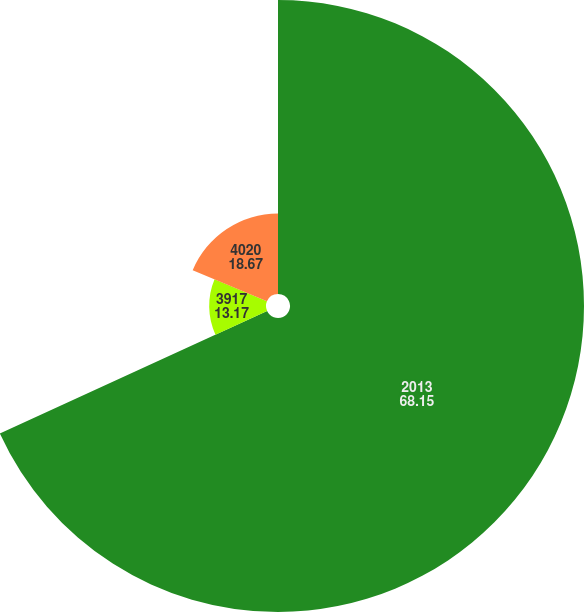Convert chart to OTSL. <chart><loc_0><loc_0><loc_500><loc_500><pie_chart><fcel>2013<fcel>3917<fcel>4020<nl><fcel>68.15%<fcel>13.17%<fcel>18.67%<nl></chart> 